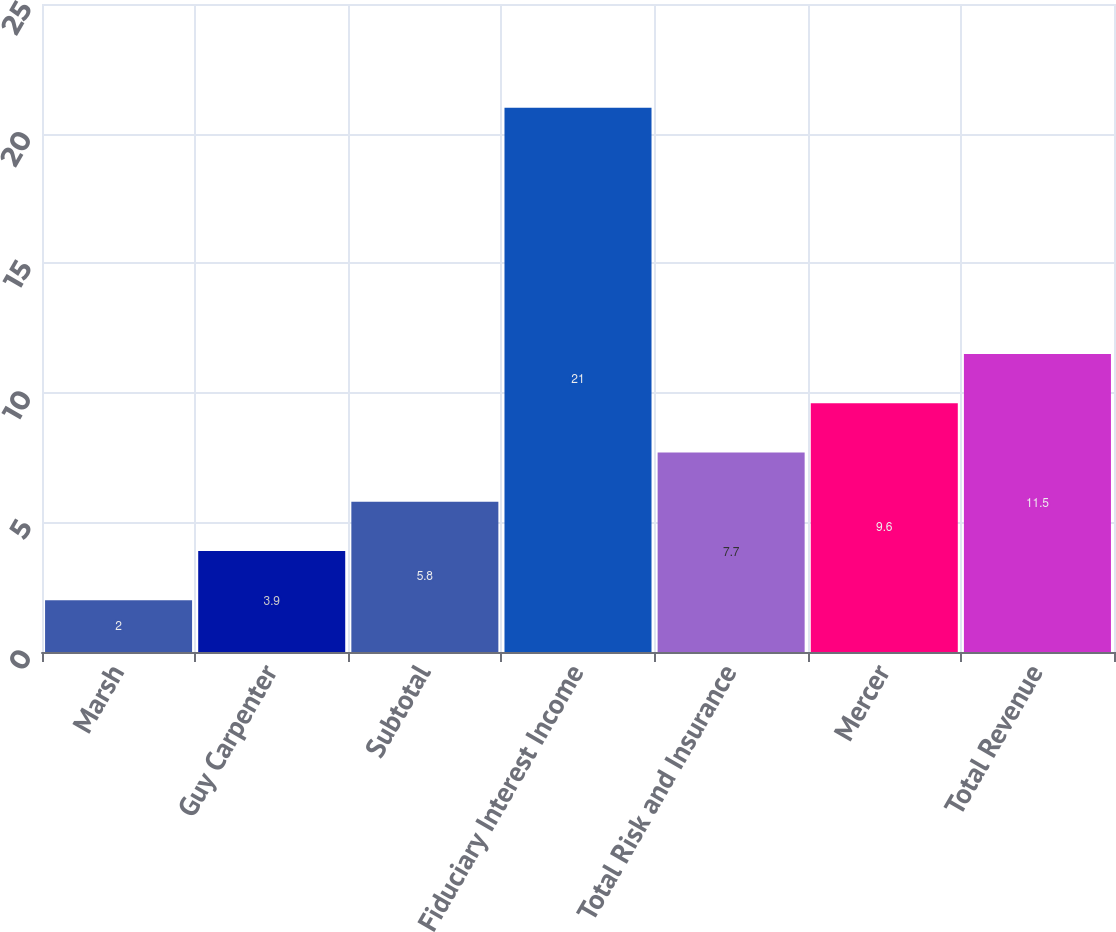<chart> <loc_0><loc_0><loc_500><loc_500><bar_chart><fcel>Marsh<fcel>Guy Carpenter<fcel>Subtotal<fcel>Fiduciary Interest Income<fcel>Total Risk and Insurance<fcel>Mercer<fcel>Total Revenue<nl><fcel>2<fcel>3.9<fcel>5.8<fcel>21<fcel>7.7<fcel>9.6<fcel>11.5<nl></chart> 